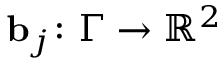Convert formula to latex. <formula><loc_0><loc_0><loc_500><loc_500>b _ { j } \colon \Gamma \to { \mathbb { R } } ^ { 2 }</formula> 